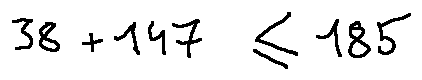Convert formula to latex. <formula><loc_0><loc_0><loc_500><loc_500>3 8 + 1 4 7 \leq 1 8 5</formula> 